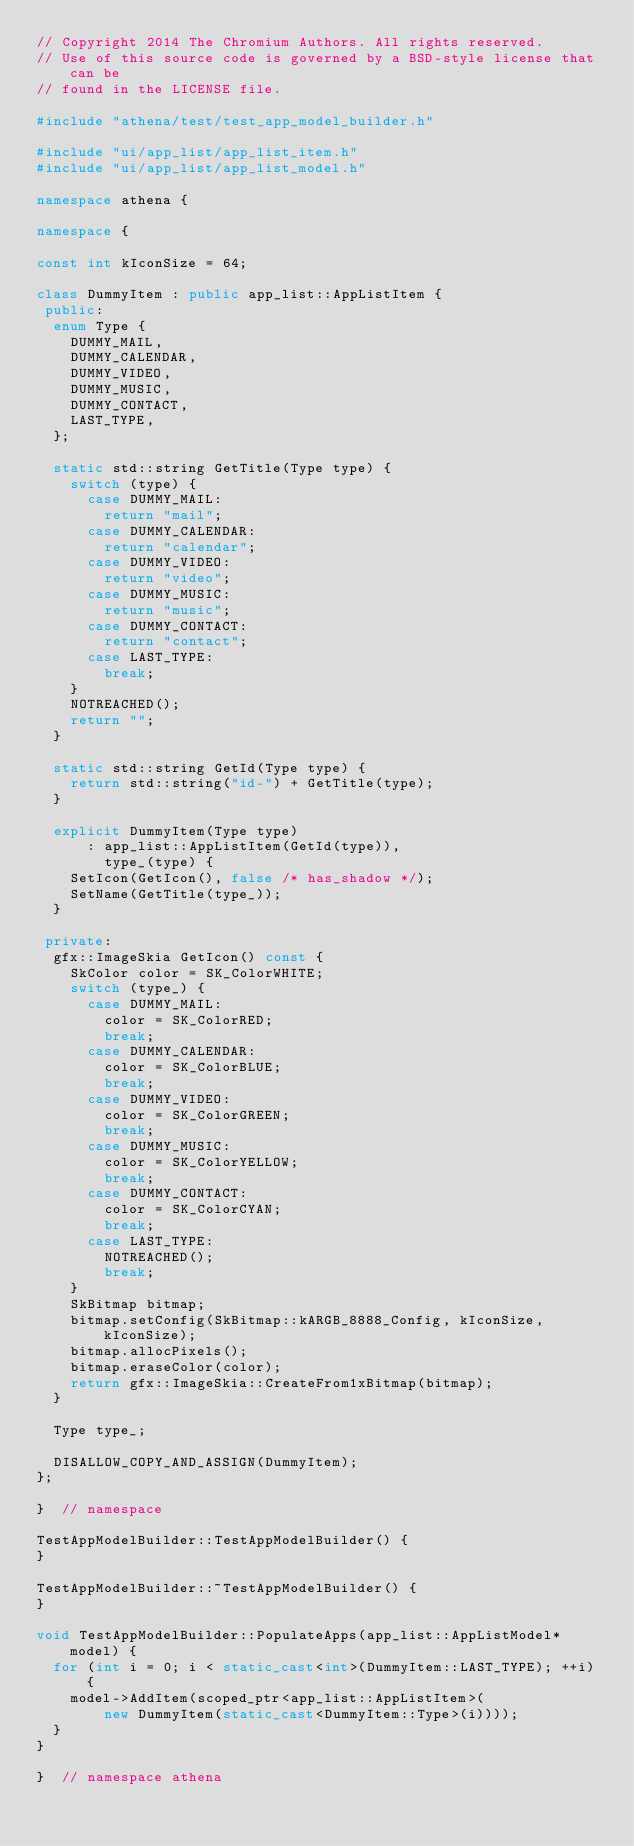<code> <loc_0><loc_0><loc_500><loc_500><_C++_>// Copyright 2014 The Chromium Authors. All rights reserved.
// Use of this source code is governed by a BSD-style license that can be
// found in the LICENSE file.

#include "athena/test/test_app_model_builder.h"

#include "ui/app_list/app_list_item.h"
#include "ui/app_list/app_list_model.h"

namespace athena {

namespace {

const int kIconSize = 64;

class DummyItem : public app_list::AppListItem {
 public:
  enum Type {
    DUMMY_MAIL,
    DUMMY_CALENDAR,
    DUMMY_VIDEO,
    DUMMY_MUSIC,
    DUMMY_CONTACT,
    LAST_TYPE,
  };

  static std::string GetTitle(Type type) {
    switch (type) {
      case DUMMY_MAIL:
        return "mail";
      case DUMMY_CALENDAR:
        return "calendar";
      case DUMMY_VIDEO:
        return "video";
      case DUMMY_MUSIC:
        return "music";
      case DUMMY_CONTACT:
        return "contact";
      case LAST_TYPE:
        break;
    }
    NOTREACHED();
    return "";
  }

  static std::string GetId(Type type) {
    return std::string("id-") + GetTitle(type);
  }

  explicit DummyItem(Type type)
      : app_list::AppListItem(GetId(type)),
        type_(type) {
    SetIcon(GetIcon(), false /* has_shadow */);
    SetName(GetTitle(type_));
  }

 private:
  gfx::ImageSkia GetIcon() const {
    SkColor color = SK_ColorWHITE;
    switch (type_) {
      case DUMMY_MAIL:
        color = SK_ColorRED;
        break;
      case DUMMY_CALENDAR:
        color = SK_ColorBLUE;
        break;
      case DUMMY_VIDEO:
        color = SK_ColorGREEN;
        break;
      case DUMMY_MUSIC:
        color = SK_ColorYELLOW;
        break;
      case DUMMY_CONTACT:
        color = SK_ColorCYAN;
        break;
      case LAST_TYPE:
        NOTREACHED();
        break;
    }
    SkBitmap bitmap;
    bitmap.setConfig(SkBitmap::kARGB_8888_Config, kIconSize, kIconSize);
    bitmap.allocPixels();
    bitmap.eraseColor(color);
    return gfx::ImageSkia::CreateFrom1xBitmap(bitmap);
  }

  Type type_;

  DISALLOW_COPY_AND_ASSIGN(DummyItem);
};

}  // namespace

TestAppModelBuilder::TestAppModelBuilder() {
}

TestAppModelBuilder::~TestAppModelBuilder() {
}

void TestAppModelBuilder::PopulateApps(app_list::AppListModel* model) {
  for (int i = 0; i < static_cast<int>(DummyItem::LAST_TYPE); ++i) {
    model->AddItem(scoped_ptr<app_list::AppListItem>(
        new DummyItem(static_cast<DummyItem::Type>(i))));
  }
}

}  // namespace athena
</code> 